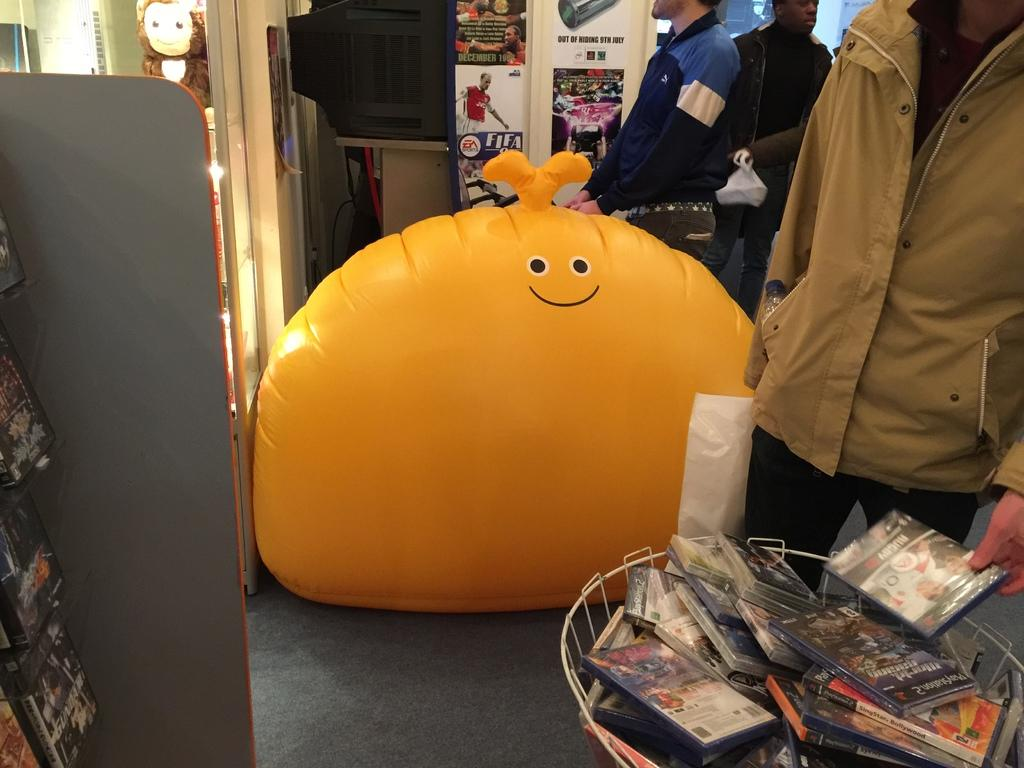<image>
Give a short and clear explanation of the subsequent image. A man is holding a Rugby game in his left hand. 